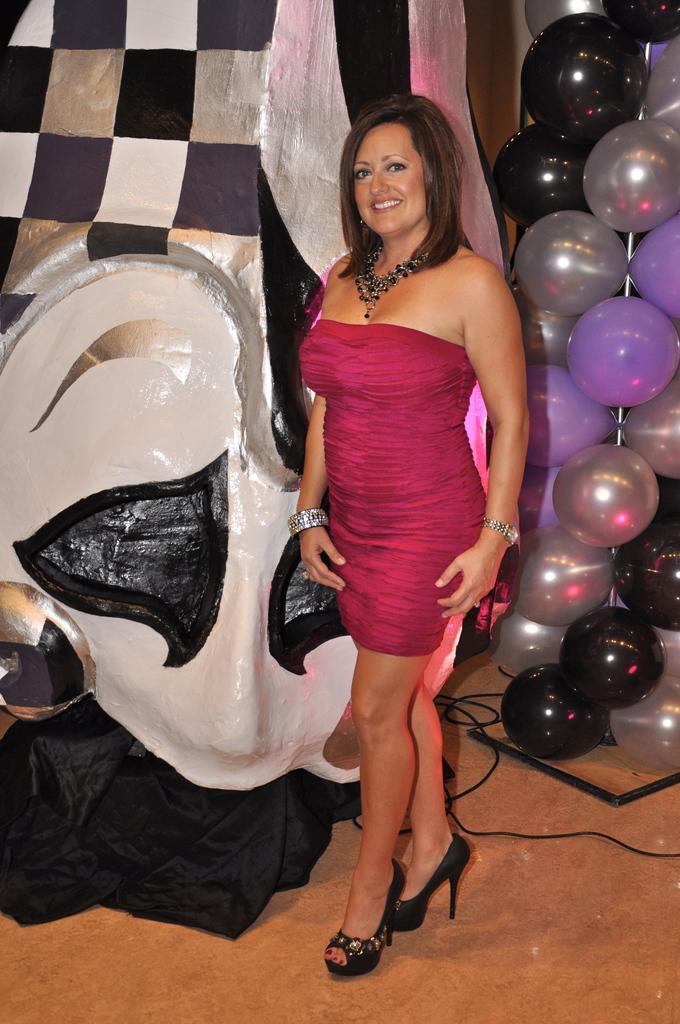Please provide a concise description of this image. Here we can see a woman is standing on the floor and she is smiling. In the background there is an object,black color cloth,balloons,cables and a stand on the floor. 